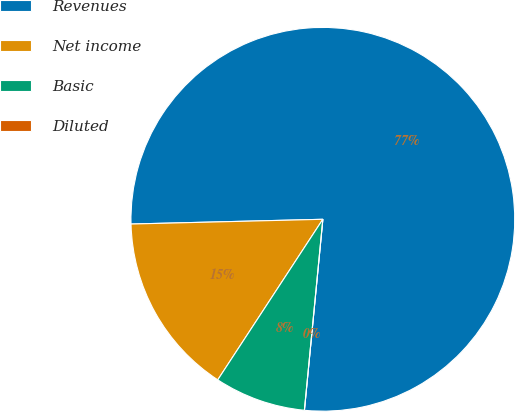Convert chart. <chart><loc_0><loc_0><loc_500><loc_500><pie_chart><fcel>Revenues<fcel>Net income<fcel>Basic<fcel>Diluted<nl><fcel>76.92%<fcel>15.38%<fcel>7.69%<fcel>0.0%<nl></chart> 